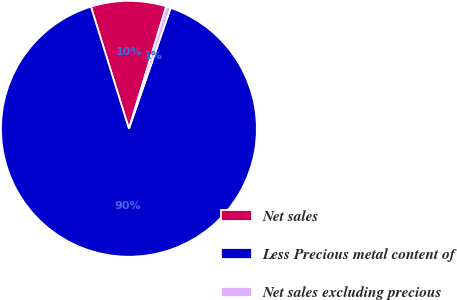<chart> <loc_0><loc_0><loc_500><loc_500><pie_chart><fcel>Net sales<fcel>Less Precious metal content of<fcel>Net sales excluding precious<nl><fcel>9.51%<fcel>89.91%<fcel>0.58%<nl></chart> 